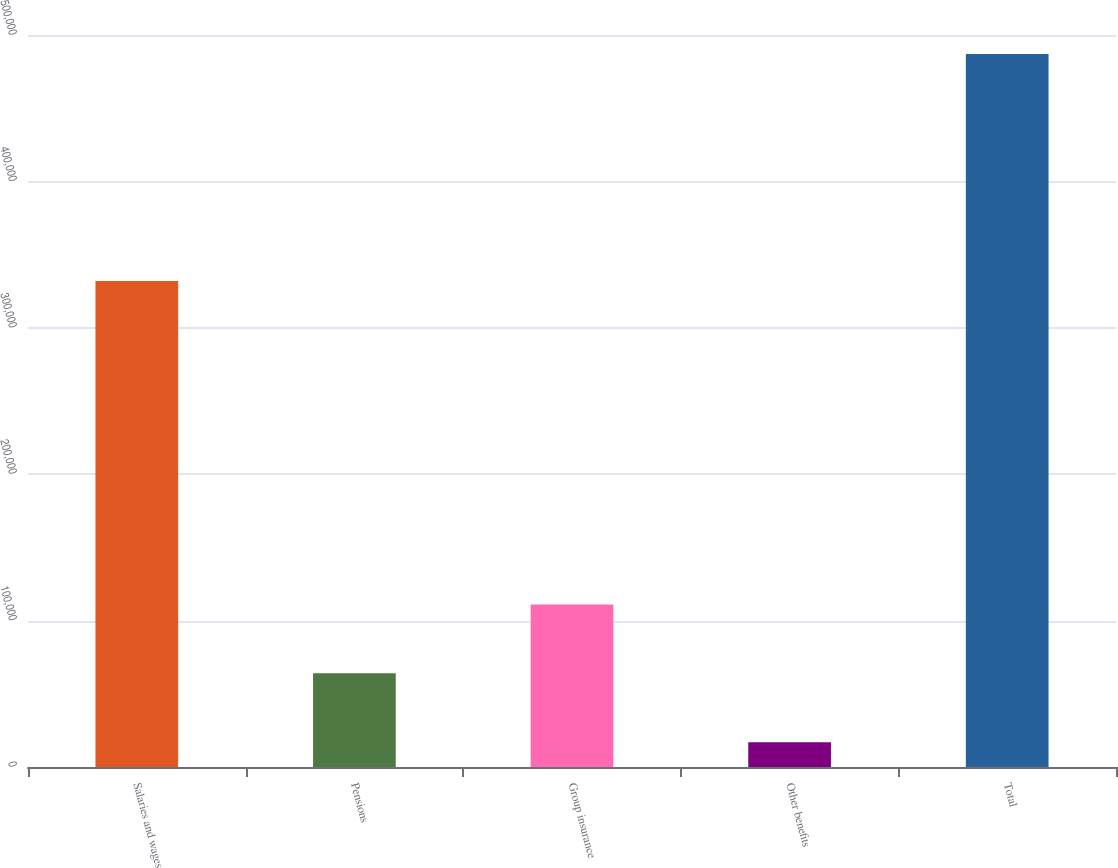Convert chart to OTSL. <chart><loc_0><loc_0><loc_500><loc_500><bar_chart><fcel>Salaries and wages<fcel>Pensions<fcel>Group insurance<fcel>Other benefits<fcel>Total<nl><fcel>331913<fcel>63964.5<fcel>110965<fcel>16964<fcel>486969<nl></chart> 